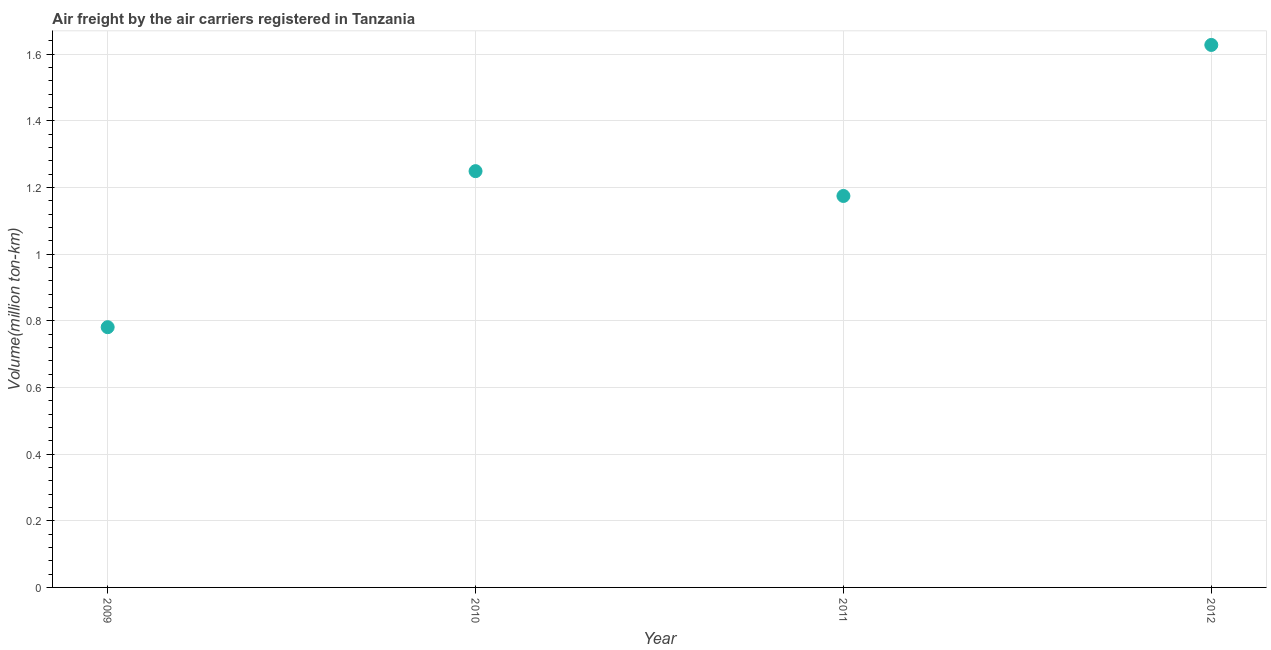What is the air freight in 2010?
Offer a terse response. 1.25. Across all years, what is the maximum air freight?
Give a very brief answer. 1.63. Across all years, what is the minimum air freight?
Keep it short and to the point. 0.78. In which year was the air freight maximum?
Keep it short and to the point. 2012. What is the sum of the air freight?
Your answer should be compact. 4.83. What is the difference between the air freight in 2009 and 2011?
Your response must be concise. -0.39. What is the average air freight per year?
Make the answer very short. 1.21. What is the median air freight?
Offer a very short reply. 1.21. In how many years, is the air freight greater than 0.08 million ton-km?
Give a very brief answer. 4. Do a majority of the years between 2012 and 2011 (inclusive) have air freight greater than 0.16 million ton-km?
Give a very brief answer. No. What is the ratio of the air freight in 2009 to that in 2011?
Your answer should be very brief. 0.66. What is the difference between the highest and the second highest air freight?
Provide a short and direct response. 0.38. Is the sum of the air freight in 2011 and 2012 greater than the maximum air freight across all years?
Keep it short and to the point. Yes. What is the difference between the highest and the lowest air freight?
Offer a terse response. 0.85. Does the air freight monotonically increase over the years?
Provide a succinct answer. No. How many years are there in the graph?
Keep it short and to the point. 4. Does the graph contain any zero values?
Provide a succinct answer. No. Does the graph contain grids?
Offer a terse response. Yes. What is the title of the graph?
Ensure brevity in your answer.  Air freight by the air carriers registered in Tanzania. What is the label or title of the Y-axis?
Offer a terse response. Volume(million ton-km). What is the Volume(million ton-km) in 2009?
Keep it short and to the point. 0.78. What is the Volume(million ton-km) in 2010?
Provide a succinct answer. 1.25. What is the Volume(million ton-km) in 2011?
Give a very brief answer. 1.17. What is the Volume(million ton-km) in 2012?
Keep it short and to the point. 1.63. What is the difference between the Volume(million ton-km) in 2009 and 2010?
Ensure brevity in your answer.  -0.47. What is the difference between the Volume(million ton-km) in 2009 and 2011?
Keep it short and to the point. -0.39. What is the difference between the Volume(million ton-km) in 2009 and 2012?
Offer a very short reply. -0.85. What is the difference between the Volume(million ton-km) in 2010 and 2011?
Your answer should be compact. 0.07. What is the difference between the Volume(million ton-km) in 2010 and 2012?
Your answer should be very brief. -0.38. What is the difference between the Volume(million ton-km) in 2011 and 2012?
Your answer should be very brief. -0.45. What is the ratio of the Volume(million ton-km) in 2009 to that in 2011?
Offer a very short reply. 0.67. What is the ratio of the Volume(million ton-km) in 2009 to that in 2012?
Make the answer very short. 0.48. What is the ratio of the Volume(million ton-km) in 2010 to that in 2011?
Provide a short and direct response. 1.06. What is the ratio of the Volume(million ton-km) in 2010 to that in 2012?
Your response must be concise. 0.77. What is the ratio of the Volume(million ton-km) in 2011 to that in 2012?
Make the answer very short. 0.72. 